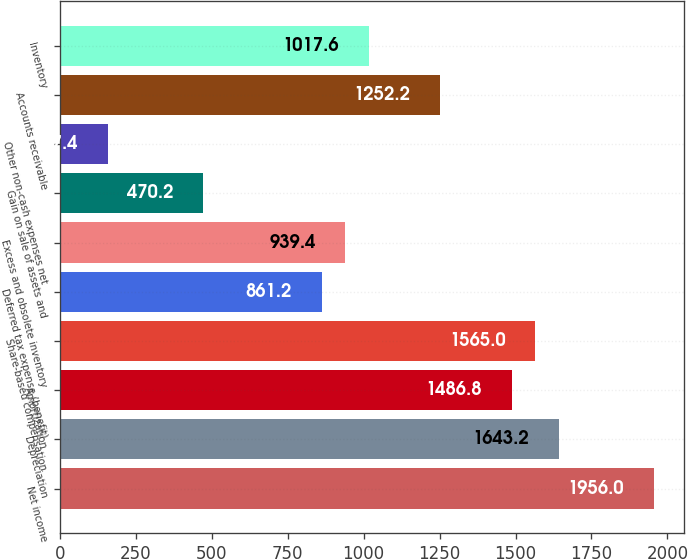Convert chart. <chart><loc_0><loc_0><loc_500><loc_500><bar_chart><fcel>Net income<fcel>Depreciation<fcel>Amortization<fcel>Share-based compensation<fcel>Deferred tax expense (benefit)<fcel>Excess and obsolete inventory<fcel>Gain on sale of assets and<fcel>Other non-cash expenses net<fcel>Accounts receivable<fcel>Inventory<nl><fcel>1956<fcel>1643.2<fcel>1486.8<fcel>1565<fcel>861.2<fcel>939.4<fcel>470.2<fcel>157.4<fcel>1252.2<fcel>1017.6<nl></chart> 